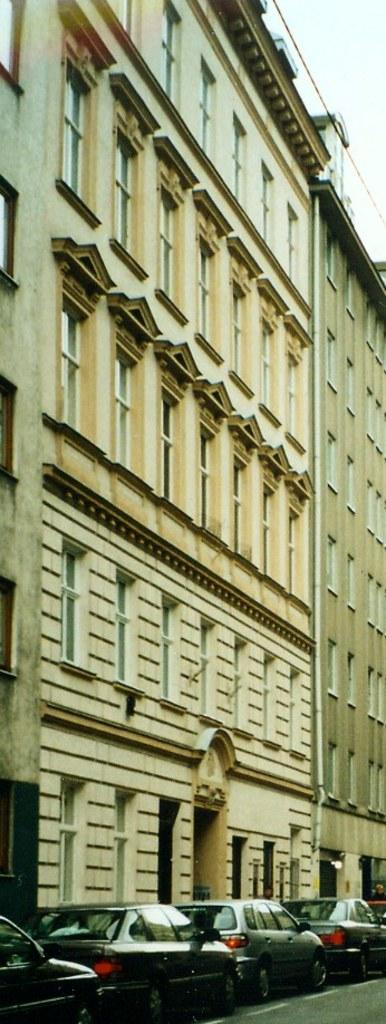What type of structures can be seen in the image? There are buildings in the image. What else can be found at the bottom of the image? Vehicles are parked at the bottom of the image. What is visible at the top of the image? The sky is visible at the top of the image. How many friends are visible in the image? There is no mention of friends or any individuals in the image, so it is impossible to determine the number of friends present. 